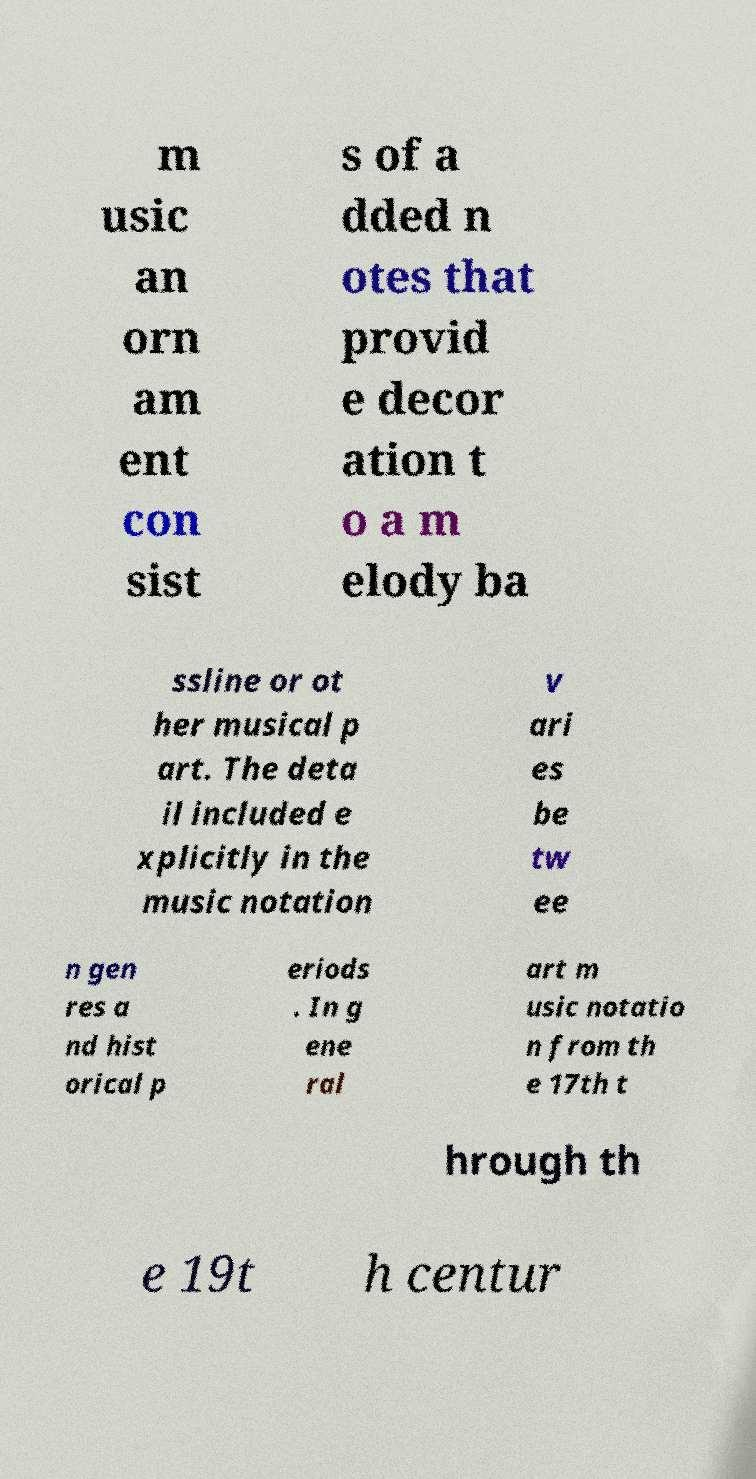I need the written content from this picture converted into text. Can you do that? m usic an orn am ent con sist s of a dded n otes that provid e decor ation t o a m elody ba ssline or ot her musical p art. The deta il included e xplicitly in the music notation v ari es be tw ee n gen res a nd hist orical p eriods . In g ene ral art m usic notatio n from th e 17th t hrough th e 19t h centur 